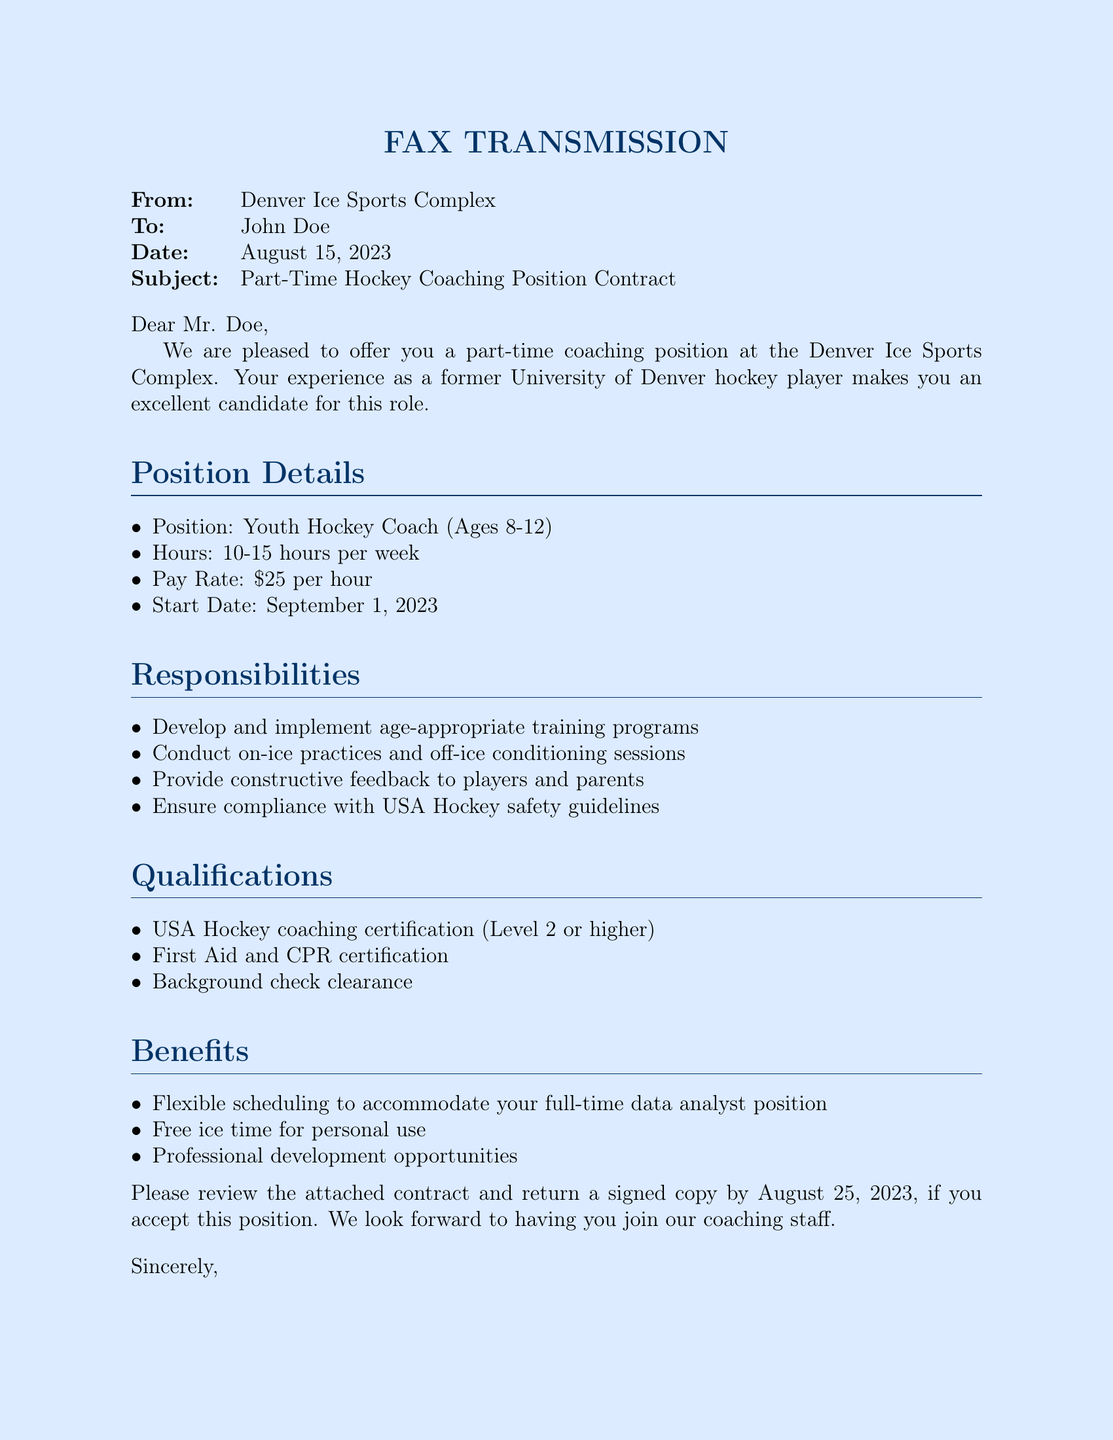What is the position title offered? The position title offered in the document is "Youth Hockey Coach (Ages 8-12)."
Answer: Youth Hockey Coach (Ages 8-12) What is the pay rate per hour? The document states that the pay rate is $25 per hour.
Answer: $25 per hour When is the start date for the coaching position? The start date for the coaching position is provided in the document as September 1, 2023.
Answer: September 1, 2023 What qualifications are required for the position? The required qualifications include USA Hockey coaching certification, First Aid and CPR certification, and background check clearance.
Answer: USA Hockey coaching certification, First Aid and CPR certification, background check clearance Who is the sender of the fax? The sender of the fax is Sarah Johnson, the Hockey Programs Director.
Answer: Sarah Johnson How many hours per week is the coaching position expected to require? The document notes that the coaching position is expected to require 10-15 hours per week.
Answer: 10-15 hours per week What benefits are mentioned in the document? Benefits listed in the document include flexible scheduling, free ice time, and professional development opportunities.
Answer: Flexible scheduling, free ice time, professional development opportunities By what date should the signed contract be returned? The document specifies that the signed contract should be returned by August 25, 2023.
Answer: August 25, 2023 What is the subject of the fax? The subject of the fax is stated as "Part-Time Hockey Coaching Position Contract."
Answer: Part-Time Hockey Coaching Position Contract 